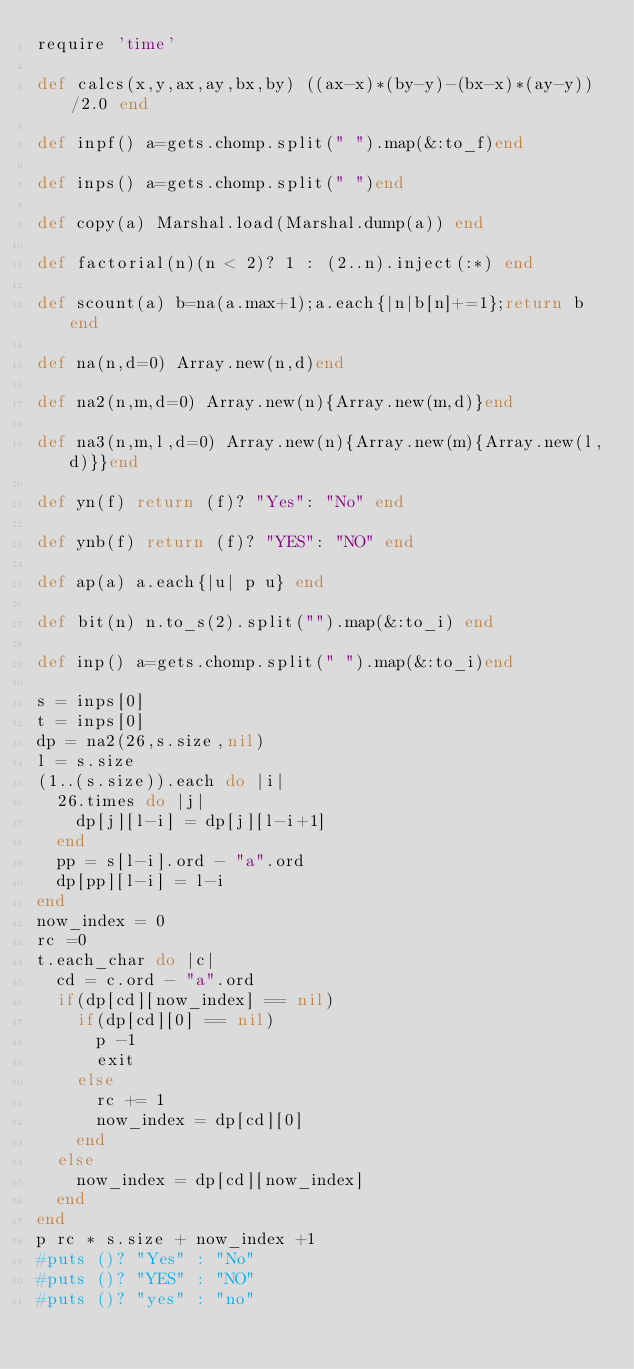Convert code to text. <code><loc_0><loc_0><loc_500><loc_500><_Ruby_>require 'time'

def calcs(x,y,ax,ay,bx,by) ((ax-x)*(by-y)-(bx-x)*(ay-y))/2.0 end

def inpf() a=gets.chomp.split(" ").map(&:to_f)end

def inps() a=gets.chomp.split(" ")end

def copy(a) Marshal.load(Marshal.dump(a)) end

def factorial(n)(n < 2)? 1 : (2..n).inject(:*) end

def scount(a) b=na(a.max+1);a.each{|n|b[n]+=1};return b end

def na(n,d=0) Array.new(n,d)end

def na2(n,m,d=0) Array.new(n){Array.new(m,d)}end

def na3(n,m,l,d=0) Array.new(n){Array.new(m){Array.new(l,d)}}end

def yn(f) return (f)? "Yes": "No" end

def ynb(f) return (f)? "YES": "NO" end

def ap(a) a.each{|u| p u} end

def bit(n) n.to_s(2).split("").map(&:to_i) end

def inp() a=gets.chomp.split(" ").map(&:to_i)end

s = inps[0]
t = inps[0]
dp = na2(26,s.size,nil)
l = s.size
(1..(s.size)).each do |i|
  26.times do |j|
    dp[j][l-i] = dp[j][l-i+1]
  end
  pp = s[l-i].ord - "a".ord
  dp[pp][l-i] = l-i
end
now_index = 0
rc =0
t.each_char do |c|
  cd = c.ord - "a".ord
  if(dp[cd][now_index] == nil)
    if(dp[cd][0] == nil)
      p -1
      exit
    else
      rc += 1
      now_index = dp[cd][0]
    end
  else
    now_index = dp[cd][now_index]
  end
end
p rc * s.size + now_index +1
#puts ()? "Yes" : "No"
#puts ()? "YES" : "NO"
#puts ()? "yes" : "no"</code> 